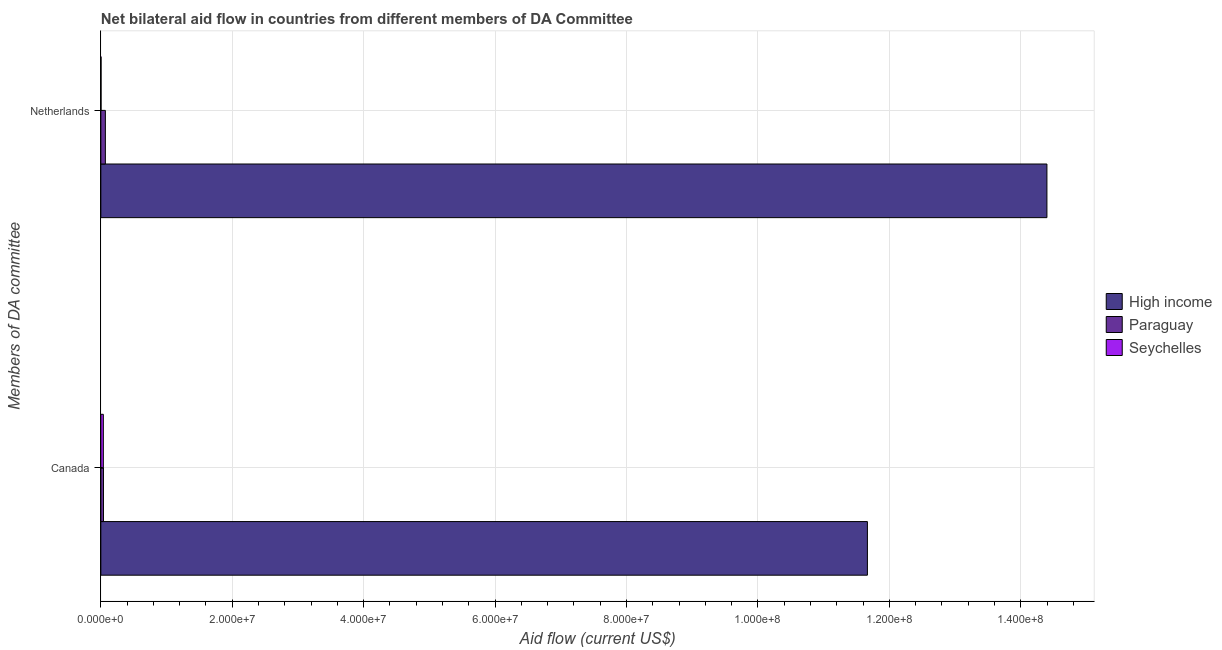How many groups of bars are there?
Offer a very short reply. 2. Are the number of bars on each tick of the Y-axis equal?
Give a very brief answer. Yes. How many bars are there on the 1st tick from the bottom?
Offer a very short reply. 3. What is the label of the 1st group of bars from the top?
Give a very brief answer. Netherlands. What is the amount of aid given by canada in High income?
Give a very brief answer. 1.17e+08. Across all countries, what is the maximum amount of aid given by canada?
Keep it short and to the point. 1.17e+08. Across all countries, what is the minimum amount of aid given by canada?
Offer a terse response. 3.80e+05. In which country was the amount of aid given by canada minimum?
Ensure brevity in your answer.  Seychelles. What is the total amount of aid given by canada in the graph?
Offer a terse response. 1.17e+08. What is the difference between the amount of aid given by netherlands in Paraguay and that in High income?
Your answer should be compact. -1.43e+08. What is the difference between the amount of aid given by netherlands in Paraguay and the amount of aid given by canada in High income?
Provide a short and direct response. -1.16e+08. What is the average amount of aid given by canada per country?
Make the answer very short. 3.91e+07. What is the difference between the amount of aid given by netherlands and amount of aid given by canada in High income?
Ensure brevity in your answer.  2.73e+07. What is the ratio of the amount of aid given by canada in Seychelles to that in High income?
Your response must be concise. 0. What does the 1st bar from the top in Canada represents?
Offer a very short reply. Seychelles. Are all the bars in the graph horizontal?
Offer a terse response. Yes. Are the values on the major ticks of X-axis written in scientific E-notation?
Keep it short and to the point. Yes. How many legend labels are there?
Make the answer very short. 3. What is the title of the graph?
Provide a succinct answer. Net bilateral aid flow in countries from different members of DA Committee. What is the label or title of the X-axis?
Provide a short and direct response. Aid flow (current US$). What is the label or title of the Y-axis?
Provide a succinct answer. Members of DA committee. What is the Aid flow (current US$) of High income in Canada?
Provide a succinct answer. 1.17e+08. What is the Aid flow (current US$) of Seychelles in Canada?
Provide a succinct answer. 3.80e+05. What is the Aid flow (current US$) of High income in Netherlands?
Make the answer very short. 1.44e+08. What is the Aid flow (current US$) of Paraguay in Netherlands?
Your answer should be very brief. 6.90e+05. What is the Aid flow (current US$) of Seychelles in Netherlands?
Your answer should be very brief. 3.00e+04. Across all Members of DA committee, what is the maximum Aid flow (current US$) in High income?
Your answer should be very brief. 1.44e+08. Across all Members of DA committee, what is the maximum Aid flow (current US$) of Paraguay?
Keep it short and to the point. 6.90e+05. Across all Members of DA committee, what is the maximum Aid flow (current US$) in Seychelles?
Your answer should be very brief. 3.80e+05. Across all Members of DA committee, what is the minimum Aid flow (current US$) of High income?
Your answer should be very brief. 1.17e+08. Across all Members of DA committee, what is the minimum Aid flow (current US$) in Seychelles?
Ensure brevity in your answer.  3.00e+04. What is the total Aid flow (current US$) in High income in the graph?
Provide a succinct answer. 2.61e+08. What is the total Aid flow (current US$) in Paraguay in the graph?
Make the answer very short. 1.09e+06. What is the difference between the Aid flow (current US$) of High income in Canada and that in Netherlands?
Make the answer very short. -2.73e+07. What is the difference between the Aid flow (current US$) in Seychelles in Canada and that in Netherlands?
Provide a short and direct response. 3.50e+05. What is the difference between the Aid flow (current US$) in High income in Canada and the Aid flow (current US$) in Paraguay in Netherlands?
Offer a terse response. 1.16e+08. What is the difference between the Aid flow (current US$) of High income in Canada and the Aid flow (current US$) of Seychelles in Netherlands?
Your answer should be very brief. 1.17e+08. What is the average Aid flow (current US$) of High income per Members of DA committee?
Offer a very short reply. 1.30e+08. What is the average Aid flow (current US$) in Paraguay per Members of DA committee?
Your response must be concise. 5.45e+05. What is the average Aid flow (current US$) of Seychelles per Members of DA committee?
Offer a very short reply. 2.05e+05. What is the difference between the Aid flow (current US$) in High income and Aid flow (current US$) in Paraguay in Canada?
Keep it short and to the point. 1.16e+08. What is the difference between the Aid flow (current US$) in High income and Aid flow (current US$) in Seychelles in Canada?
Keep it short and to the point. 1.16e+08. What is the difference between the Aid flow (current US$) in Paraguay and Aid flow (current US$) in Seychelles in Canada?
Give a very brief answer. 2.00e+04. What is the difference between the Aid flow (current US$) of High income and Aid flow (current US$) of Paraguay in Netherlands?
Make the answer very short. 1.43e+08. What is the difference between the Aid flow (current US$) in High income and Aid flow (current US$) in Seychelles in Netherlands?
Keep it short and to the point. 1.44e+08. What is the difference between the Aid flow (current US$) of Paraguay and Aid flow (current US$) of Seychelles in Netherlands?
Your response must be concise. 6.60e+05. What is the ratio of the Aid flow (current US$) of High income in Canada to that in Netherlands?
Make the answer very short. 0.81. What is the ratio of the Aid flow (current US$) of Paraguay in Canada to that in Netherlands?
Provide a succinct answer. 0.58. What is the ratio of the Aid flow (current US$) of Seychelles in Canada to that in Netherlands?
Your response must be concise. 12.67. What is the difference between the highest and the second highest Aid flow (current US$) in High income?
Offer a terse response. 2.73e+07. What is the difference between the highest and the second highest Aid flow (current US$) of Paraguay?
Provide a succinct answer. 2.90e+05. What is the difference between the highest and the lowest Aid flow (current US$) of High income?
Your response must be concise. 2.73e+07. What is the difference between the highest and the lowest Aid flow (current US$) of Paraguay?
Your response must be concise. 2.90e+05. 